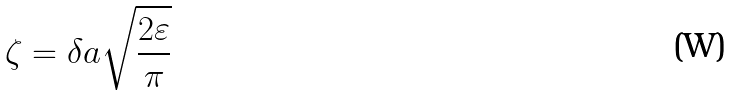<formula> <loc_0><loc_0><loc_500><loc_500>\zeta = \delta a \sqrt { \frac { 2 \varepsilon } { \pi } }</formula> 